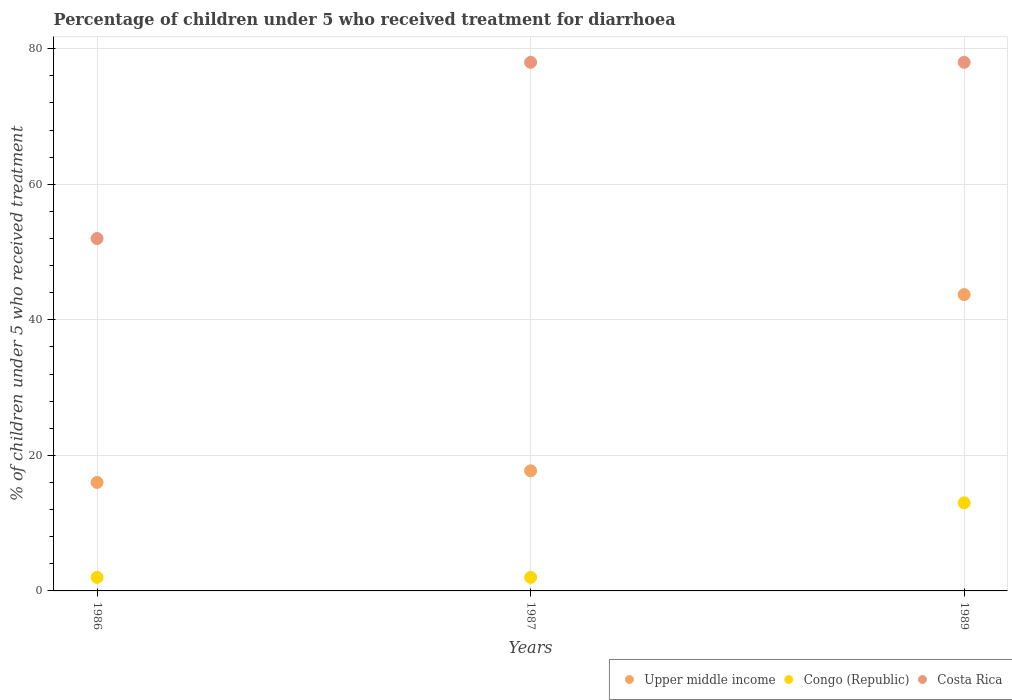Is the number of dotlines equal to the number of legend labels?
Keep it short and to the point. Yes. What is the percentage of children who received treatment for diarrhoea  in Congo (Republic) in 1987?
Keep it short and to the point. 2. Across all years, what is the maximum percentage of children who received treatment for diarrhoea  in Upper middle income?
Provide a short and direct response. 43.73. In which year was the percentage of children who received treatment for diarrhoea  in Congo (Republic) maximum?
Offer a terse response. 1989. In which year was the percentage of children who received treatment for diarrhoea  in Congo (Republic) minimum?
Ensure brevity in your answer.  1986. What is the total percentage of children who received treatment for diarrhoea  in Upper middle income in the graph?
Provide a succinct answer. 77.47. What is the difference between the percentage of children who received treatment for diarrhoea  in Costa Rica in 1986 and that in 1989?
Offer a terse response. -26. What is the difference between the percentage of children who received treatment for diarrhoea  in Congo (Republic) in 1986 and the percentage of children who received treatment for diarrhoea  in Costa Rica in 1987?
Your response must be concise. -76. What is the average percentage of children who received treatment for diarrhoea  in Costa Rica per year?
Ensure brevity in your answer.  69.33. In the year 1989, what is the difference between the percentage of children who received treatment for diarrhoea  in Congo (Republic) and percentage of children who received treatment for diarrhoea  in Upper middle income?
Provide a short and direct response. -30.73. In how many years, is the percentage of children who received treatment for diarrhoea  in Upper middle income greater than 76 %?
Your answer should be compact. 0. What is the ratio of the percentage of children who received treatment for diarrhoea  in Upper middle income in 1987 to that in 1989?
Make the answer very short. 0.41. What is the difference between the highest and the second highest percentage of children who received treatment for diarrhoea  in Upper middle income?
Keep it short and to the point. 26. What is the difference between the highest and the lowest percentage of children who received treatment for diarrhoea  in Costa Rica?
Your response must be concise. 26. Does the percentage of children who received treatment for diarrhoea  in Congo (Republic) monotonically increase over the years?
Your response must be concise. No. Is the percentage of children who received treatment for diarrhoea  in Congo (Republic) strictly less than the percentage of children who received treatment for diarrhoea  in Upper middle income over the years?
Give a very brief answer. Yes. How many years are there in the graph?
Offer a very short reply. 3. What is the difference between two consecutive major ticks on the Y-axis?
Your answer should be compact. 20. Are the values on the major ticks of Y-axis written in scientific E-notation?
Your answer should be compact. No. Does the graph contain grids?
Ensure brevity in your answer.  Yes. Where does the legend appear in the graph?
Your answer should be very brief. Bottom right. How many legend labels are there?
Provide a succinct answer. 3. How are the legend labels stacked?
Provide a succinct answer. Horizontal. What is the title of the graph?
Your answer should be very brief. Percentage of children under 5 who received treatment for diarrhoea. Does "Cameroon" appear as one of the legend labels in the graph?
Your answer should be compact. No. What is the label or title of the Y-axis?
Provide a short and direct response. % of children under 5 who received treatment. What is the % of children under 5 who received treatment in Upper middle income in 1986?
Keep it short and to the point. 16.01. What is the % of children under 5 who received treatment in Congo (Republic) in 1986?
Ensure brevity in your answer.  2. What is the % of children under 5 who received treatment in Upper middle income in 1987?
Your answer should be very brief. 17.73. What is the % of children under 5 who received treatment in Congo (Republic) in 1987?
Ensure brevity in your answer.  2. What is the % of children under 5 who received treatment of Costa Rica in 1987?
Provide a succinct answer. 78. What is the % of children under 5 who received treatment of Upper middle income in 1989?
Offer a very short reply. 43.73. Across all years, what is the maximum % of children under 5 who received treatment in Upper middle income?
Ensure brevity in your answer.  43.73. Across all years, what is the maximum % of children under 5 who received treatment in Costa Rica?
Your answer should be compact. 78. Across all years, what is the minimum % of children under 5 who received treatment of Upper middle income?
Make the answer very short. 16.01. Across all years, what is the minimum % of children under 5 who received treatment of Congo (Republic)?
Your response must be concise. 2. What is the total % of children under 5 who received treatment in Upper middle income in the graph?
Make the answer very short. 77.47. What is the total % of children under 5 who received treatment in Costa Rica in the graph?
Your answer should be compact. 208. What is the difference between the % of children under 5 who received treatment in Upper middle income in 1986 and that in 1987?
Offer a terse response. -1.72. What is the difference between the % of children under 5 who received treatment in Congo (Republic) in 1986 and that in 1987?
Offer a terse response. 0. What is the difference between the % of children under 5 who received treatment of Upper middle income in 1986 and that in 1989?
Give a very brief answer. -27.72. What is the difference between the % of children under 5 who received treatment in Congo (Republic) in 1986 and that in 1989?
Offer a terse response. -11. What is the difference between the % of children under 5 who received treatment of Upper middle income in 1987 and that in 1989?
Offer a terse response. -26. What is the difference between the % of children under 5 who received treatment in Upper middle income in 1986 and the % of children under 5 who received treatment in Congo (Republic) in 1987?
Keep it short and to the point. 14.01. What is the difference between the % of children under 5 who received treatment in Upper middle income in 1986 and the % of children under 5 who received treatment in Costa Rica in 1987?
Provide a succinct answer. -61.99. What is the difference between the % of children under 5 who received treatment in Congo (Republic) in 1986 and the % of children under 5 who received treatment in Costa Rica in 1987?
Keep it short and to the point. -76. What is the difference between the % of children under 5 who received treatment of Upper middle income in 1986 and the % of children under 5 who received treatment of Congo (Republic) in 1989?
Offer a very short reply. 3.01. What is the difference between the % of children under 5 who received treatment in Upper middle income in 1986 and the % of children under 5 who received treatment in Costa Rica in 1989?
Make the answer very short. -61.99. What is the difference between the % of children under 5 who received treatment of Congo (Republic) in 1986 and the % of children under 5 who received treatment of Costa Rica in 1989?
Your answer should be compact. -76. What is the difference between the % of children under 5 who received treatment in Upper middle income in 1987 and the % of children under 5 who received treatment in Congo (Republic) in 1989?
Provide a short and direct response. 4.73. What is the difference between the % of children under 5 who received treatment of Upper middle income in 1987 and the % of children under 5 who received treatment of Costa Rica in 1989?
Offer a terse response. -60.27. What is the difference between the % of children under 5 who received treatment of Congo (Republic) in 1987 and the % of children under 5 who received treatment of Costa Rica in 1989?
Offer a very short reply. -76. What is the average % of children under 5 who received treatment in Upper middle income per year?
Provide a short and direct response. 25.82. What is the average % of children under 5 who received treatment of Congo (Republic) per year?
Offer a very short reply. 5.67. What is the average % of children under 5 who received treatment in Costa Rica per year?
Provide a short and direct response. 69.33. In the year 1986, what is the difference between the % of children under 5 who received treatment of Upper middle income and % of children under 5 who received treatment of Congo (Republic)?
Provide a short and direct response. 14.01. In the year 1986, what is the difference between the % of children under 5 who received treatment of Upper middle income and % of children under 5 who received treatment of Costa Rica?
Provide a succinct answer. -35.99. In the year 1987, what is the difference between the % of children under 5 who received treatment in Upper middle income and % of children under 5 who received treatment in Congo (Republic)?
Your response must be concise. 15.73. In the year 1987, what is the difference between the % of children under 5 who received treatment in Upper middle income and % of children under 5 who received treatment in Costa Rica?
Keep it short and to the point. -60.27. In the year 1987, what is the difference between the % of children under 5 who received treatment in Congo (Republic) and % of children under 5 who received treatment in Costa Rica?
Provide a short and direct response. -76. In the year 1989, what is the difference between the % of children under 5 who received treatment in Upper middle income and % of children under 5 who received treatment in Congo (Republic)?
Keep it short and to the point. 30.73. In the year 1989, what is the difference between the % of children under 5 who received treatment in Upper middle income and % of children under 5 who received treatment in Costa Rica?
Give a very brief answer. -34.27. In the year 1989, what is the difference between the % of children under 5 who received treatment of Congo (Republic) and % of children under 5 who received treatment of Costa Rica?
Make the answer very short. -65. What is the ratio of the % of children under 5 who received treatment of Upper middle income in 1986 to that in 1987?
Make the answer very short. 0.9. What is the ratio of the % of children under 5 who received treatment of Costa Rica in 1986 to that in 1987?
Make the answer very short. 0.67. What is the ratio of the % of children under 5 who received treatment in Upper middle income in 1986 to that in 1989?
Your answer should be compact. 0.37. What is the ratio of the % of children under 5 who received treatment in Congo (Republic) in 1986 to that in 1989?
Keep it short and to the point. 0.15. What is the ratio of the % of children under 5 who received treatment in Costa Rica in 1986 to that in 1989?
Provide a succinct answer. 0.67. What is the ratio of the % of children under 5 who received treatment in Upper middle income in 1987 to that in 1989?
Offer a terse response. 0.41. What is the ratio of the % of children under 5 who received treatment of Congo (Republic) in 1987 to that in 1989?
Make the answer very short. 0.15. What is the ratio of the % of children under 5 who received treatment of Costa Rica in 1987 to that in 1989?
Provide a succinct answer. 1. What is the difference between the highest and the second highest % of children under 5 who received treatment in Upper middle income?
Offer a very short reply. 26. What is the difference between the highest and the second highest % of children under 5 who received treatment of Congo (Republic)?
Give a very brief answer. 11. What is the difference between the highest and the lowest % of children under 5 who received treatment in Upper middle income?
Provide a short and direct response. 27.72. What is the difference between the highest and the lowest % of children under 5 who received treatment in Congo (Republic)?
Your response must be concise. 11. 